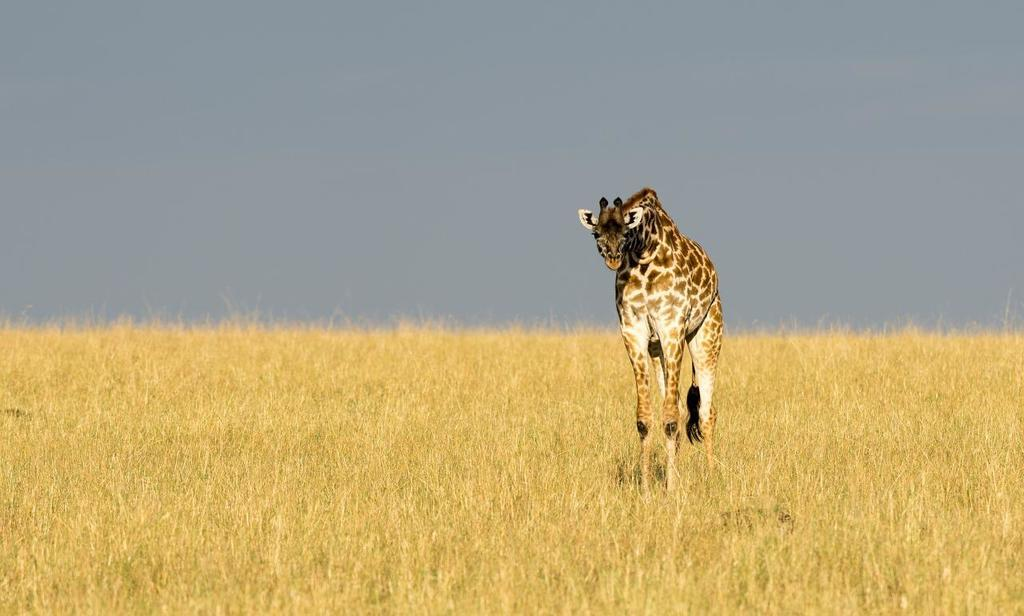What animal is present in the image? There is a giraffe in the image. What is the giraffe standing on? The giraffe is on the grass. What type of beef can be seen hanging from the mailbox in the image? There is no beef or mailbox present in the image; it features a giraffe on the grass. What key is used to unlock the giraffe's enclosure in the image? There is no key or enclosure present in the image; it simply shows a giraffe on the grass. 